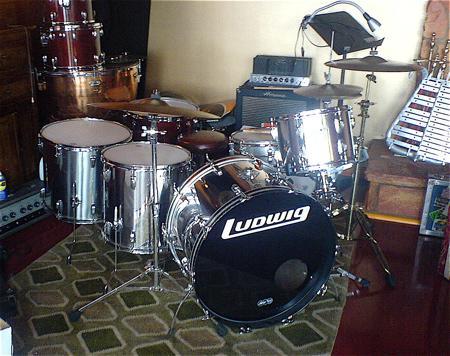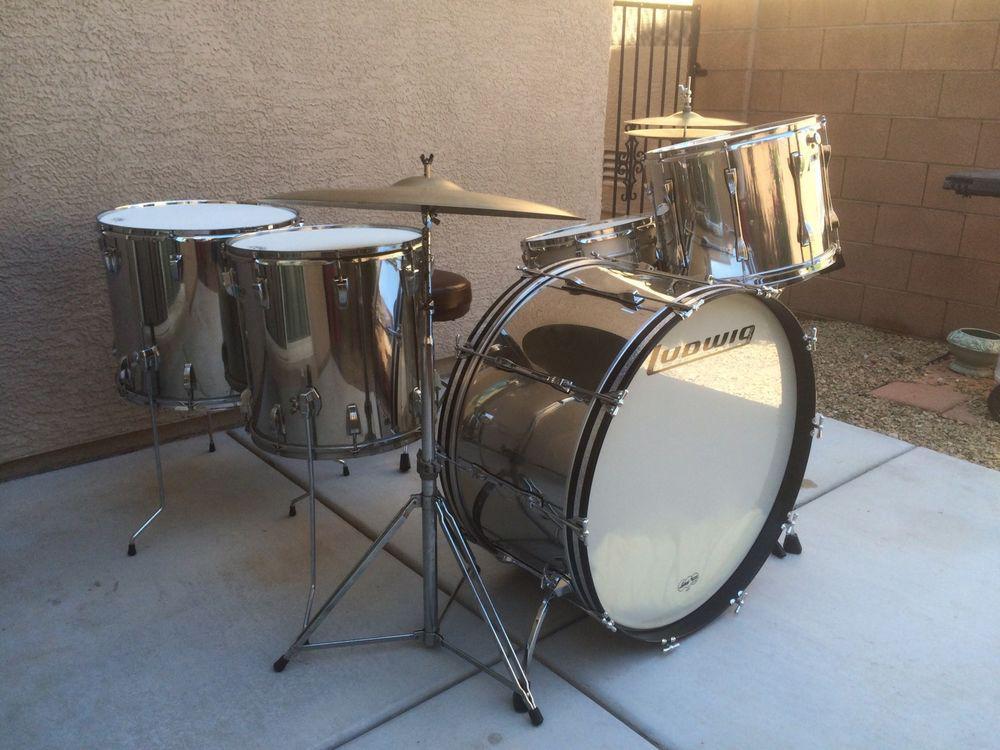The first image is the image on the left, the second image is the image on the right. Evaluate the accuracy of this statement regarding the images: "The drum set on the left includes cymbals.". Is it true? Answer yes or no. Yes. The first image is the image on the left, the second image is the image on the right. Given the left and right images, does the statement "There are three kick drums." hold true? Answer yes or no. No. 